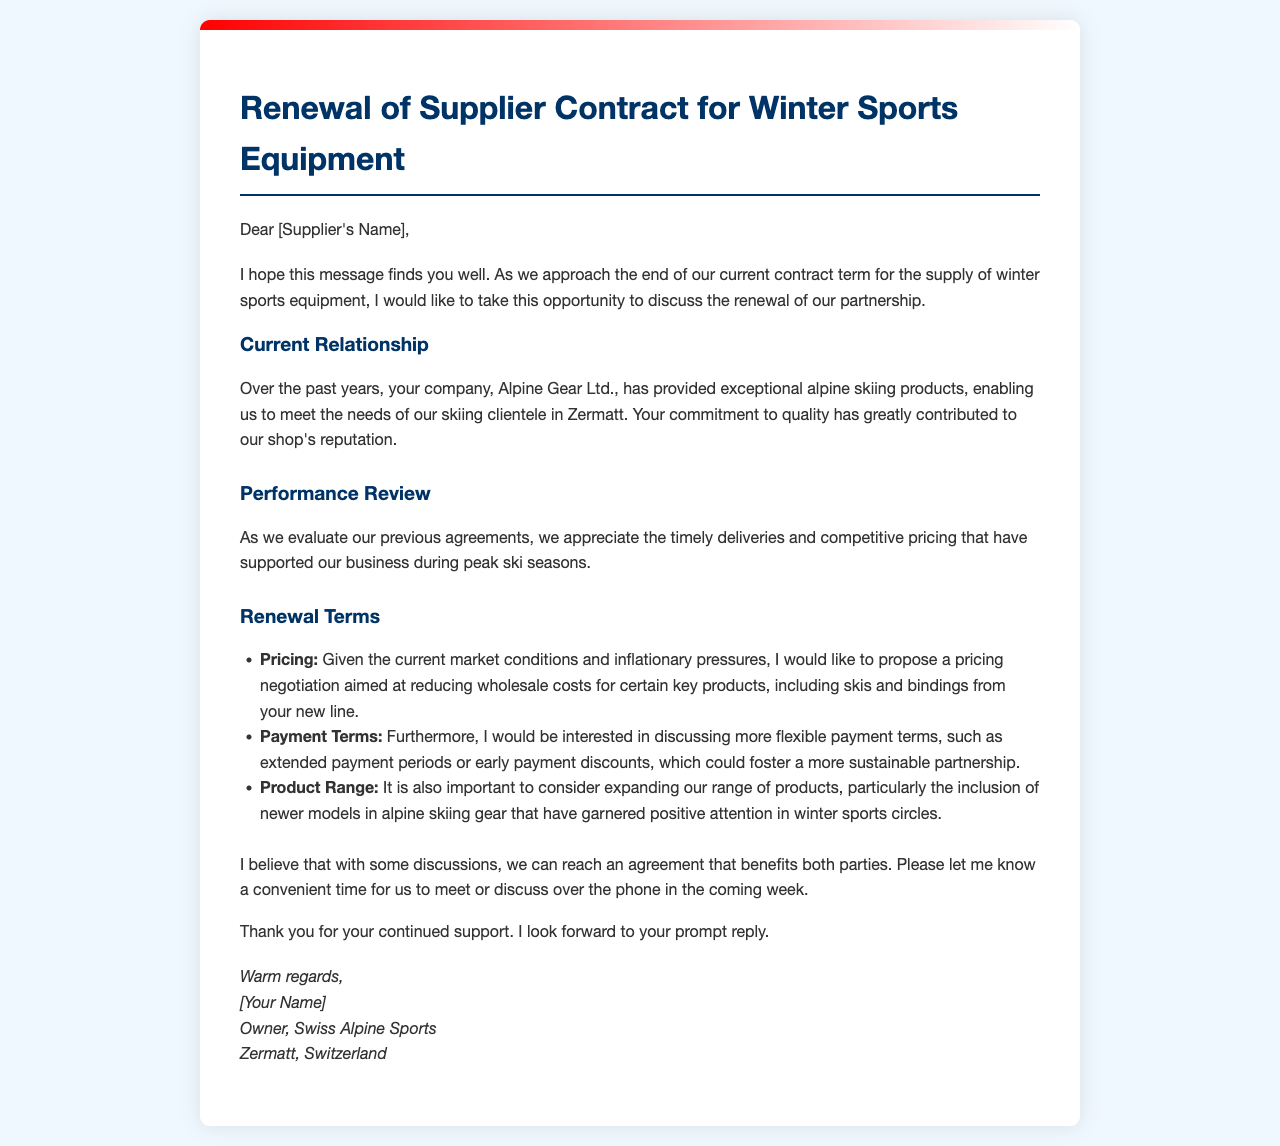What is the name of the supplier? The supplier's name is mentioned as Alpine Gear Ltd. in the document.
Answer: Alpine Gear Ltd Who is the author of the letter? The author of the letter is indicated as the owner of Swiss Alpine Sports at the end of the document.
Answer: [Your Name] What are the proposed new payment terms? The author expresses interest in discussing more flexible payment terms, which include extending payment periods or offering early payment discounts.
Answer: Flexible payment terms What specific products are mentioned for pricing negotiation? The letter points out a desire to negotiate pricing particularly for skis and bindings from a new line.
Answer: Skis and bindings What primary reason is given for the need to negotiate pricing? The author mentions that current market conditions and inflationary pressures are driving the need to negotiate pricing.
Answer: Inflationary pressures How long has the partnership lasted according to the document? The letter implies that the partnership has lasted several years, as it refers to the past years of collaboration.
Answer: Past years What location does the author mention in relation to their business? The author indicates that their shop is located in Zermatt, which is mentioned in the signature section of the letter.
Answer: Zermatt What does the author appreciate about the current supplier relationship? The author appreciates the timely deliveries and competitive pricing that have supported their business.
Answer: Timely deliveries and competitive pricing What is the main subject of the letter? The main subject of the letter revolves around the renewal of the supplier contract for winter sports equipment.
Answer: Renewal of Supplier Contract 